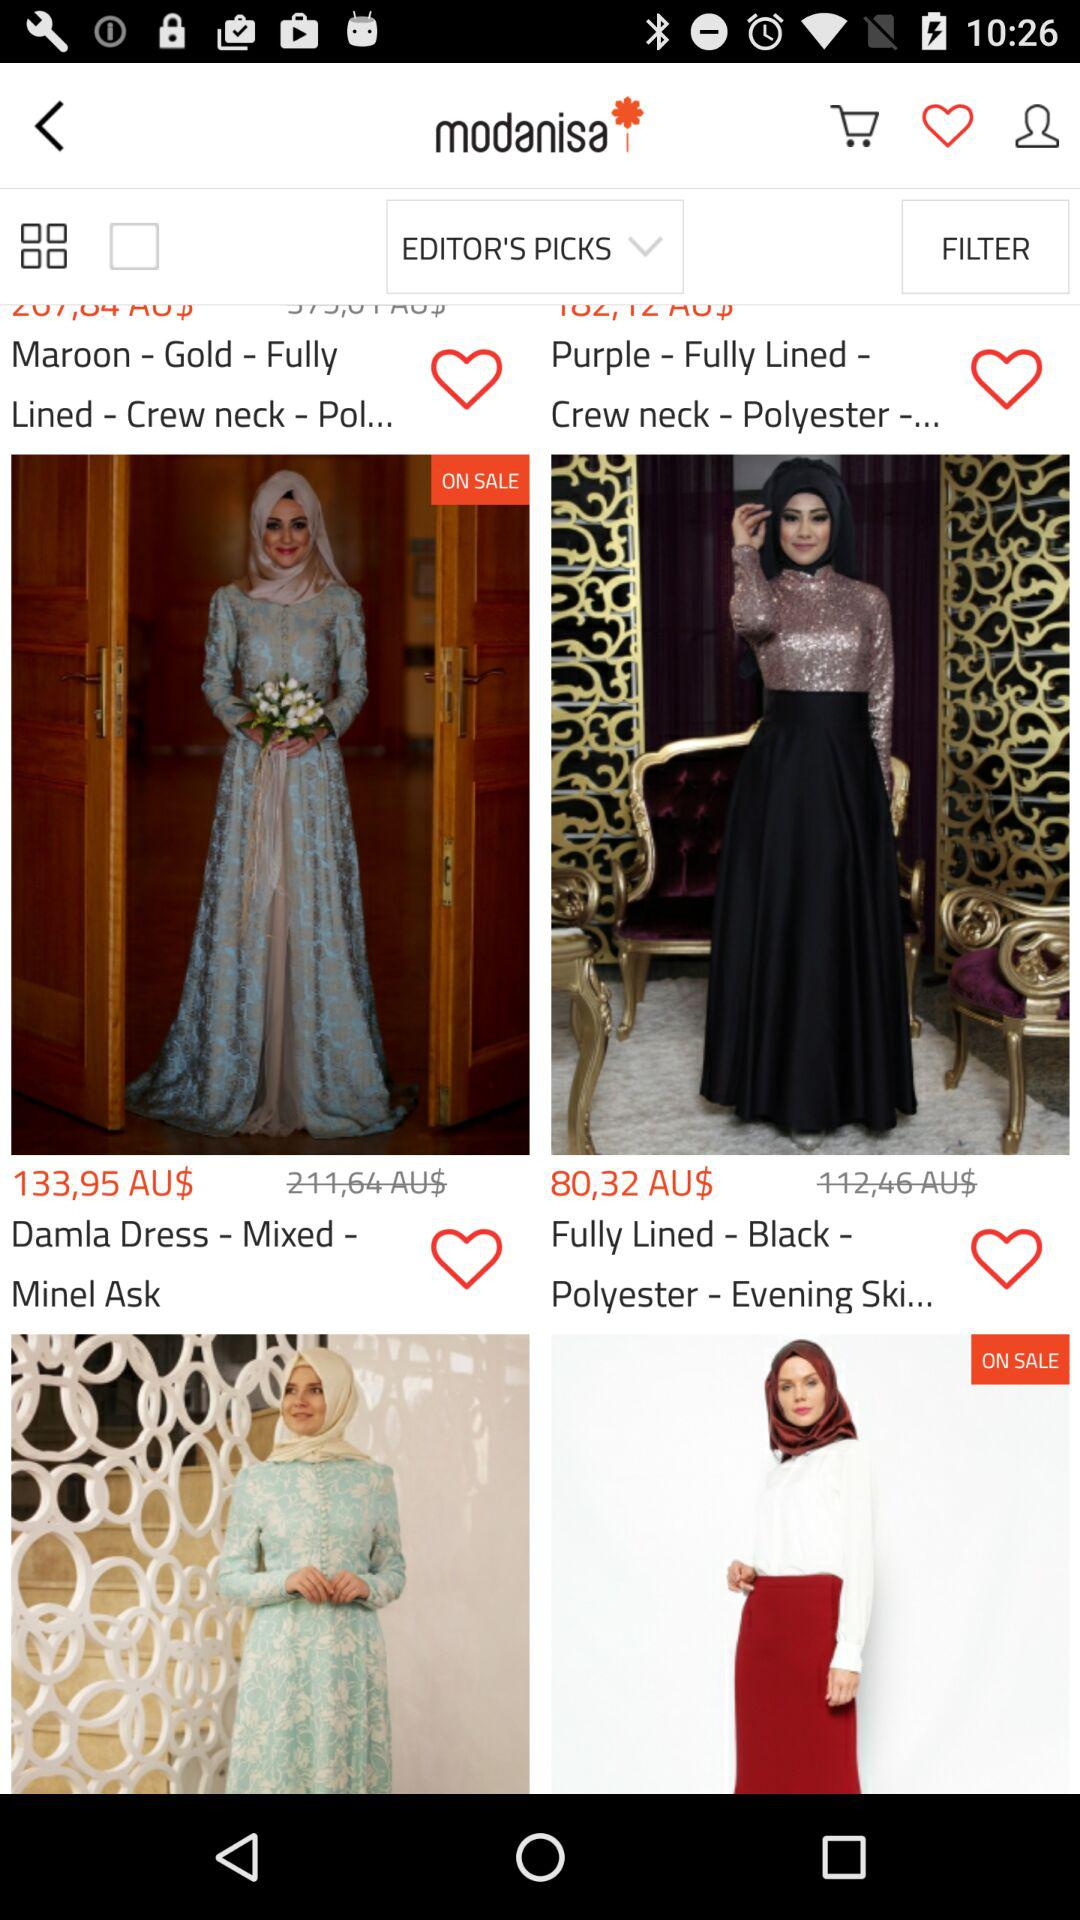What is the price of "Damla Dress"? The price is 133,95 AU$. 